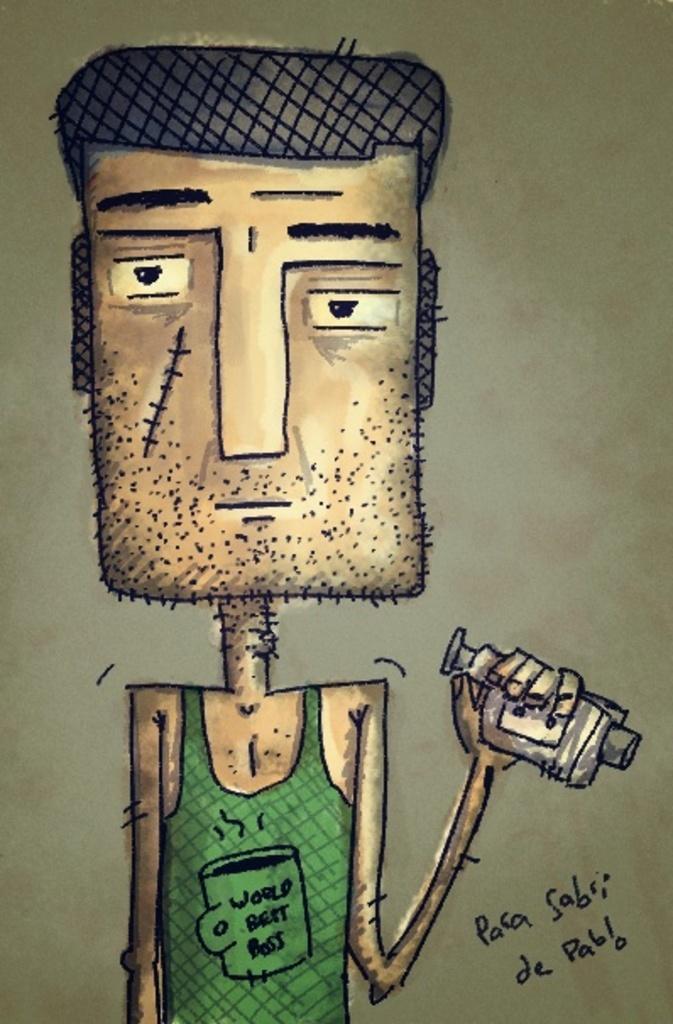How would you summarize this image in a sentence or two? In the image there is an animated picture of the man with green dress. He is holding a few items in his hand. Behind him there is a brown background. 